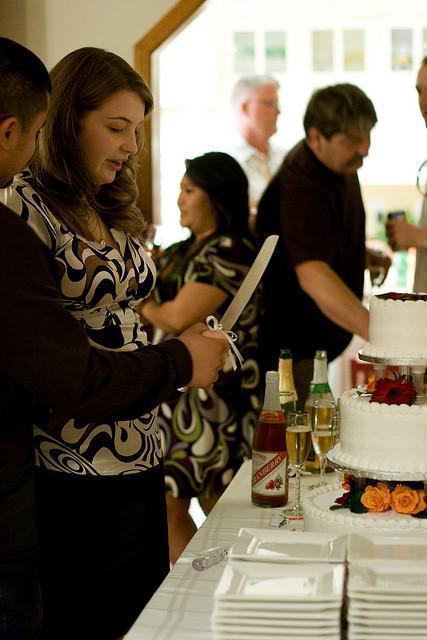What did this lady do on the day she holds this knife?
Choose the correct response, then elucidate: 'Answer: answer
Rationale: rationale.'
Options: Butcher pigs, divorce, become imprisoned, marry. Answer: marry.
Rationale: They are about to cut a wedding cake 